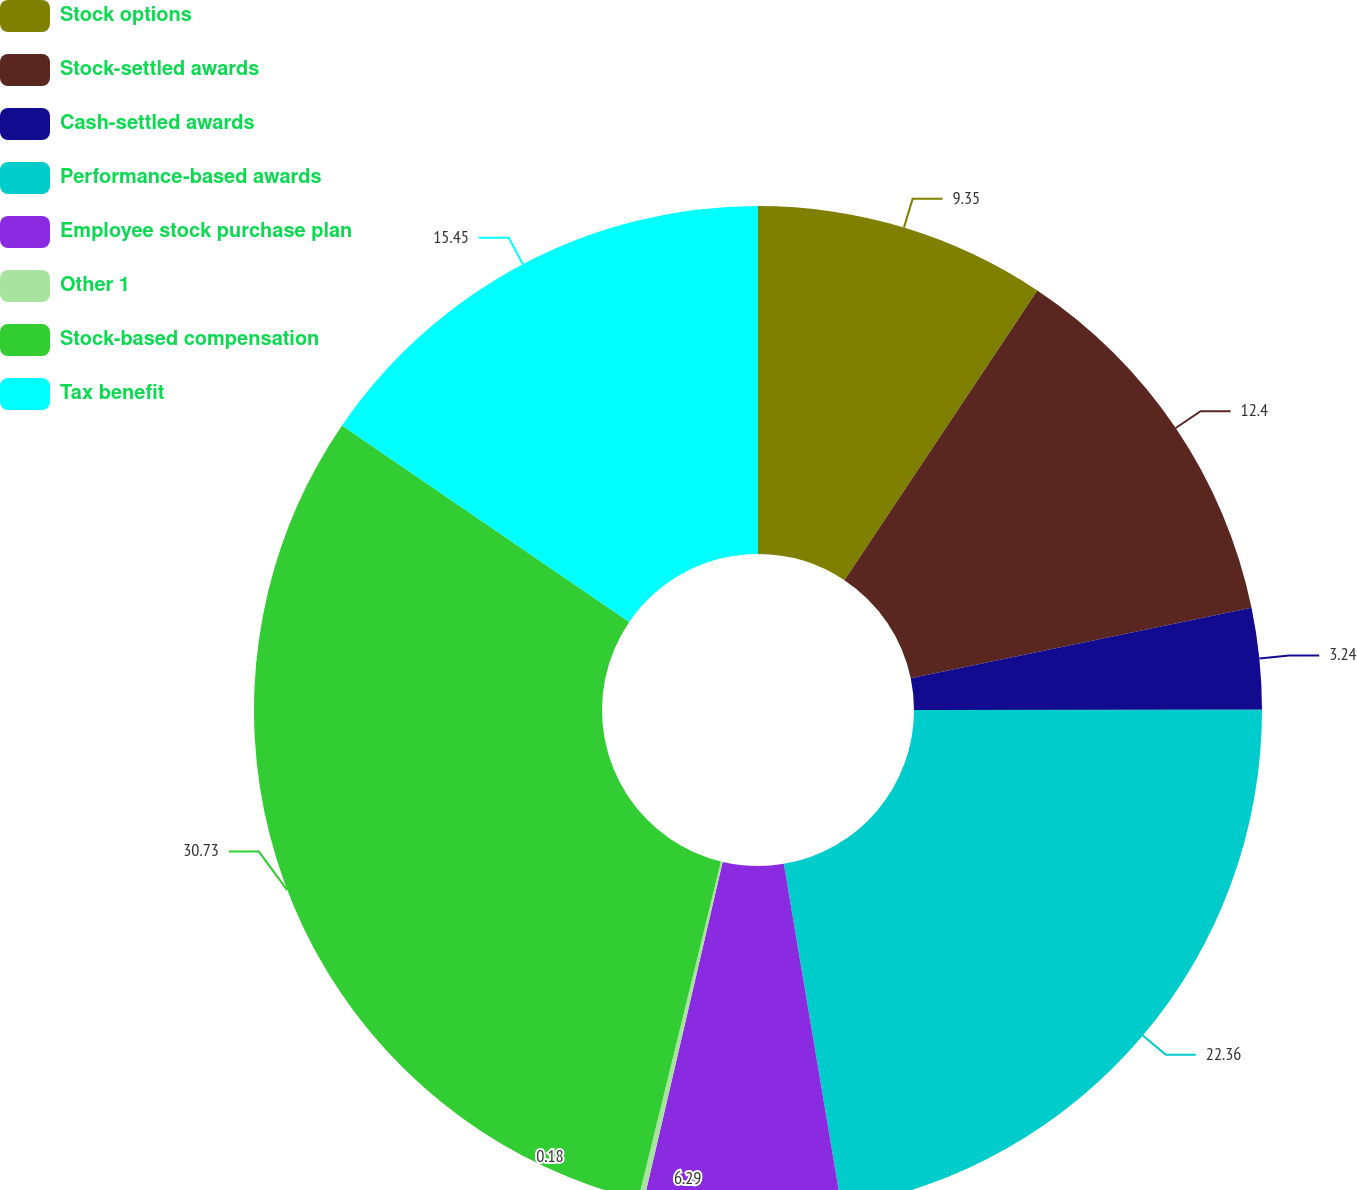Convert chart. <chart><loc_0><loc_0><loc_500><loc_500><pie_chart><fcel>Stock options<fcel>Stock-settled awards<fcel>Cash-settled awards<fcel>Performance-based awards<fcel>Employee stock purchase plan<fcel>Other 1<fcel>Stock-based compensation<fcel>Tax benefit<nl><fcel>9.35%<fcel>12.4%<fcel>3.24%<fcel>22.36%<fcel>6.29%<fcel>0.18%<fcel>30.73%<fcel>15.45%<nl></chart> 